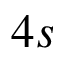<formula> <loc_0><loc_0><loc_500><loc_500>4 s</formula> 